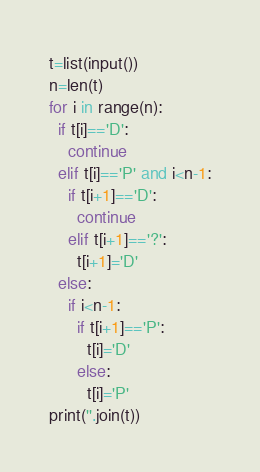Convert code to text. <code><loc_0><loc_0><loc_500><loc_500><_Python_>t=list(input())
n=len(t)
for i in range(n):
  if t[i]=='D':
    continue
  elif t[i]=='P' and i<n-1:
    if t[i+1]=='D':
      continue
    elif t[i+1]=='?':
      t[i+1]='D'
  else:
    if i<n-1:
      if t[i+1]=='P':
        t[i]='D'
      else:
        t[i]='P'
print(''.join(t))
</code> 